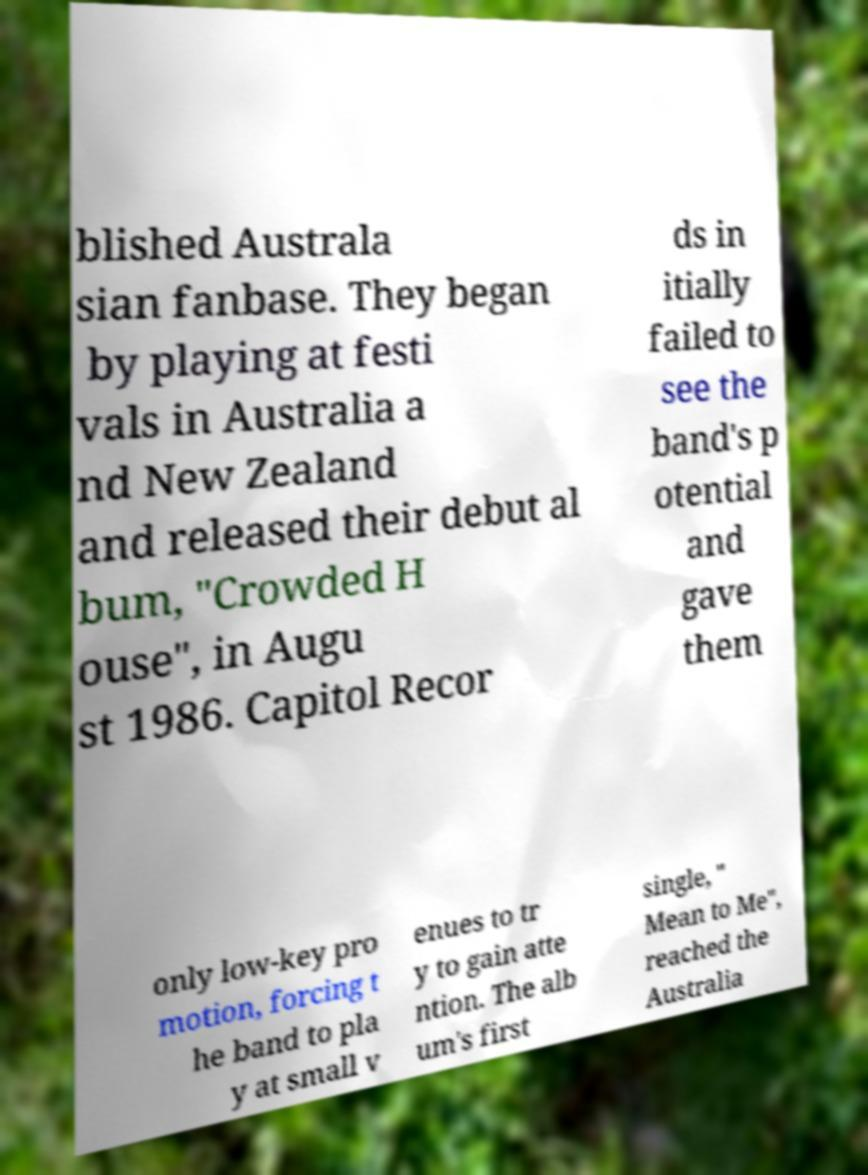Can you accurately transcribe the text from the provided image for me? blished Australa sian fanbase. They began by playing at festi vals in Australia a nd New Zealand and released their debut al bum, "Crowded H ouse", in Augu st 1986. Capitol Recor ds in itially failed to see the band's p otential and gave them only low-key pro motion, forcing t he band to pla y at small v enues to tr y to gain atte ntion. The alb um's first single, " Mean to Me", reached the Australia 